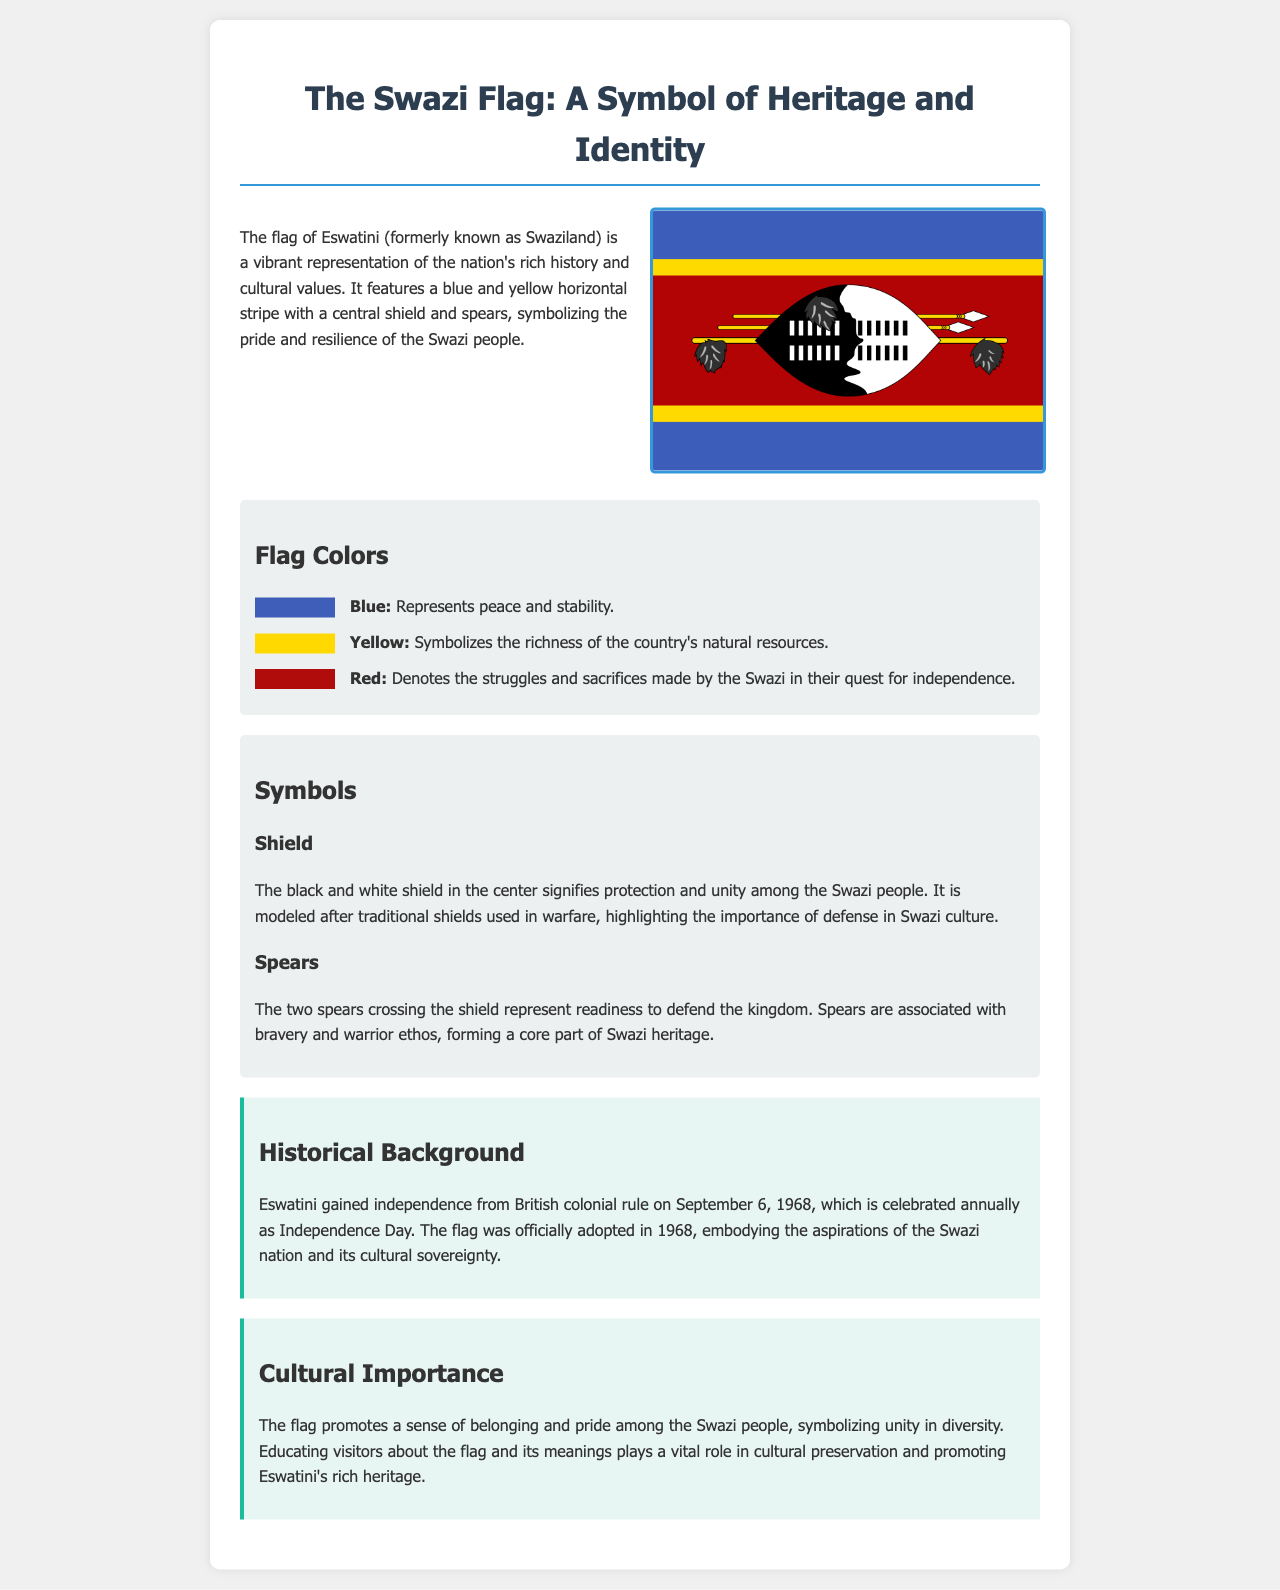What does the blue color represent? The blue color symbolizes peace and stability, as stated in the document.
Answer: Peace and stability When did Eswatini gain independence? The document states that Eswatini gained independence on September 6, 1968.
Answer: September 6, 1968 What is depicted at the center of the Swazi flag? The document indicates that a black and white shield is depicted at the center of the flag.
Answer: Shield What do the two spears represent? The document explains that the two spears represent readiness to defend the kingdom.
Answer: Readiness to defend Why is the flag important for the Swazi people? The cultural importance section highlights that the flag promotes a sense of belonging and pride among the Swazi people.
Answer: Sense of belonging and pride What color on the flag symbolizes natural resources? The document specifies that yellow symbolizes the richness of the country's natural resources.
Answer: Yellow In what year was the flag adopted? The document states that the flag was officially adopted in 1968.
Answer: 1968 What is the main purpose of educating visitors about the flag? The cultural importance section mentions that educating visitors about the flag plays a vital role in cultural preservation.
Answer: Cultural preservation 